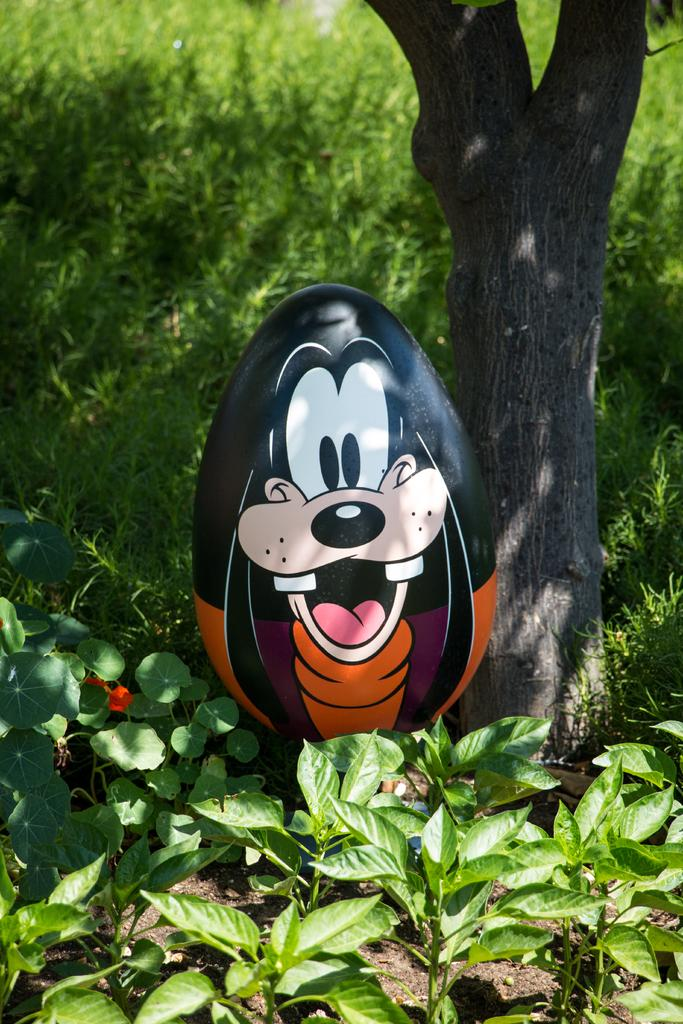What type of vegetation can be seen in the image? There are plants and grass in the image. What part of a tree is visible in the image? The bark of a tree is visible in the image. What is located in the center of the image? There is an object in the center of the image. What type of squirrel is trying to get the attention of the people in the image? There are no people or squirrels present in the image. 